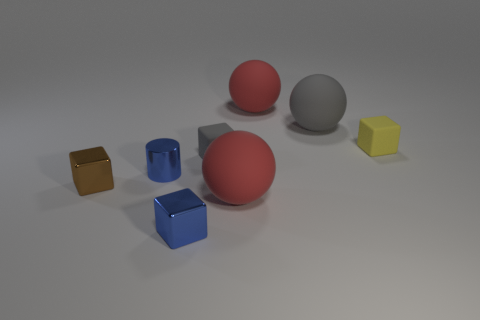How many objects are there in total, and can you describe their shapes? There are six objects in the image. There are two spheres, one red and one gray, and four cubes, colored brown, blue, red, and yellow, respectively. 